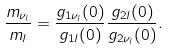<formula> <loc_0><loc_0><loc_500><loc_500>\frac { m _ { \nu _ { l } } } { m _ { l } } = \frac { g _ { 1 \nu _ { l } } ( 0 ) } { g _ { 1 l } ( 0 ) } \frac { g _ { 2 l } ( 0 ) } { g _ { 2 \nu _ { l } } ( 0 ) } .</formula> 